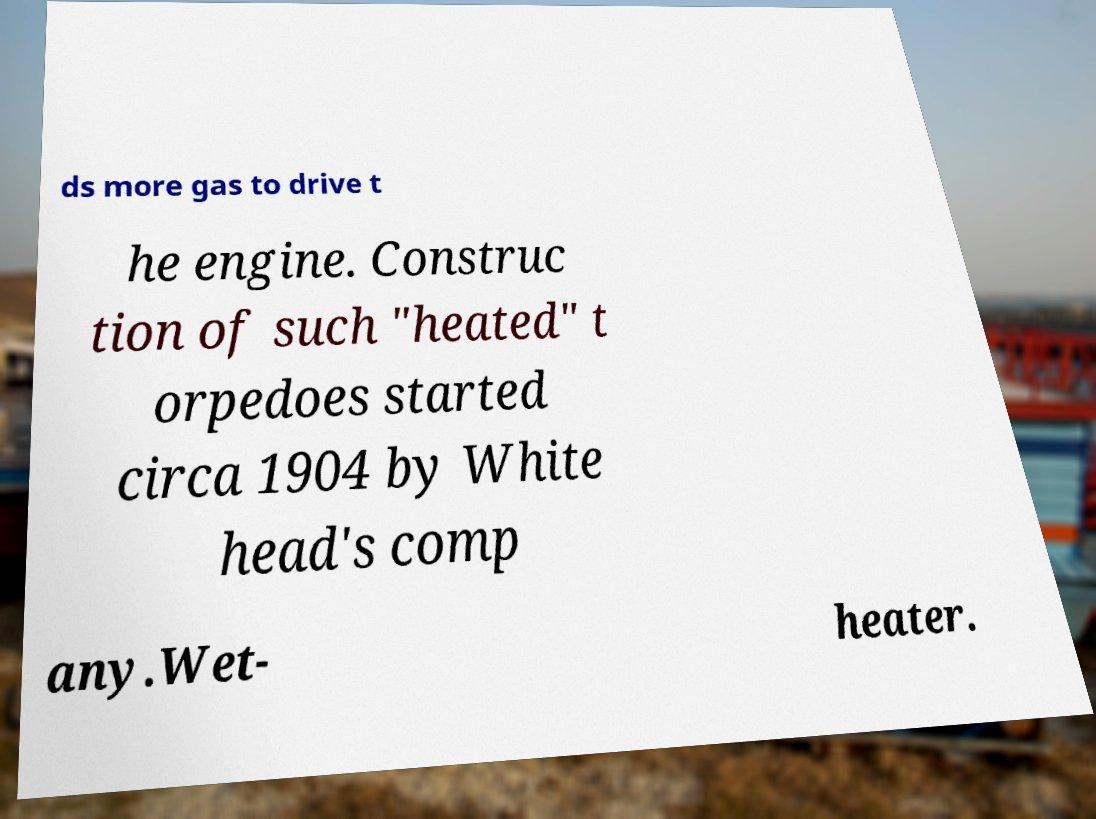What messages or text are displayed in this image? I need them in a readable, typed format. ds more gas to drive t he engine. Construc tion of such "heated" t orpedoes started circa 1904 by White head's comp any.Wet- heater. 